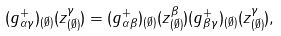<formula> <loc_0><loc_0><loc_500><loc_500>( g ^ { + } _ { \alpha \gamma } ) _ { ( \emptyset ) } ( z ^ { \gamma } _ { ( \emptyset ) } ) = ( g ^ { + } _ { \alpha \beta } ) _ { ( \emptyset ) } ( z ^ { \beta } _ { ( \emptyset ) } ) ( g ^ { + } _ { \beta \gamma } ) _ { ( \emptyset ) } ( z ^ { \gamma } _ { ( \emptyset ) } ) ,</formula> 